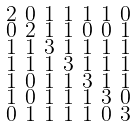Convert formula to latex. <formula><loc_0><loc_0><loc_500><loc_500>\begin{smallmatrix} 2 & 0 & 1 & 1 & 1 & 1 & 0 \\ 0 & 2 & 1 & 1 & 0 & 0 & 1 \\ 1 & 1 & 3 & 1 & 1 & 1 & 1 \\ 1 & 1 & 1 & 3 & 1 & 1 & 1 \\ 1 & 0 & 1 & 1 & 3 & 1 & 1 \\ 1 & 0 & 1 & 1 & 1 & 3 & 0 \\ 0 & 1 & 1 & 1 & 1 & 0 & 3 \end{smallmatrix}</formula> 